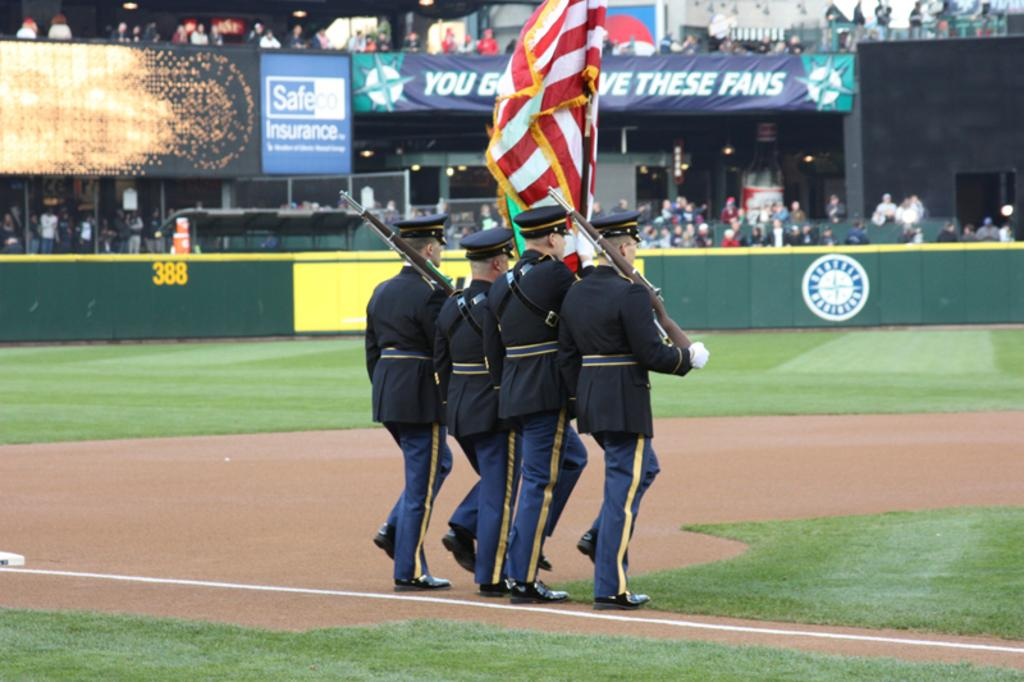<image>
Share a concise interpretation of the image provided. Square blue and white sign with Safeco on it. 